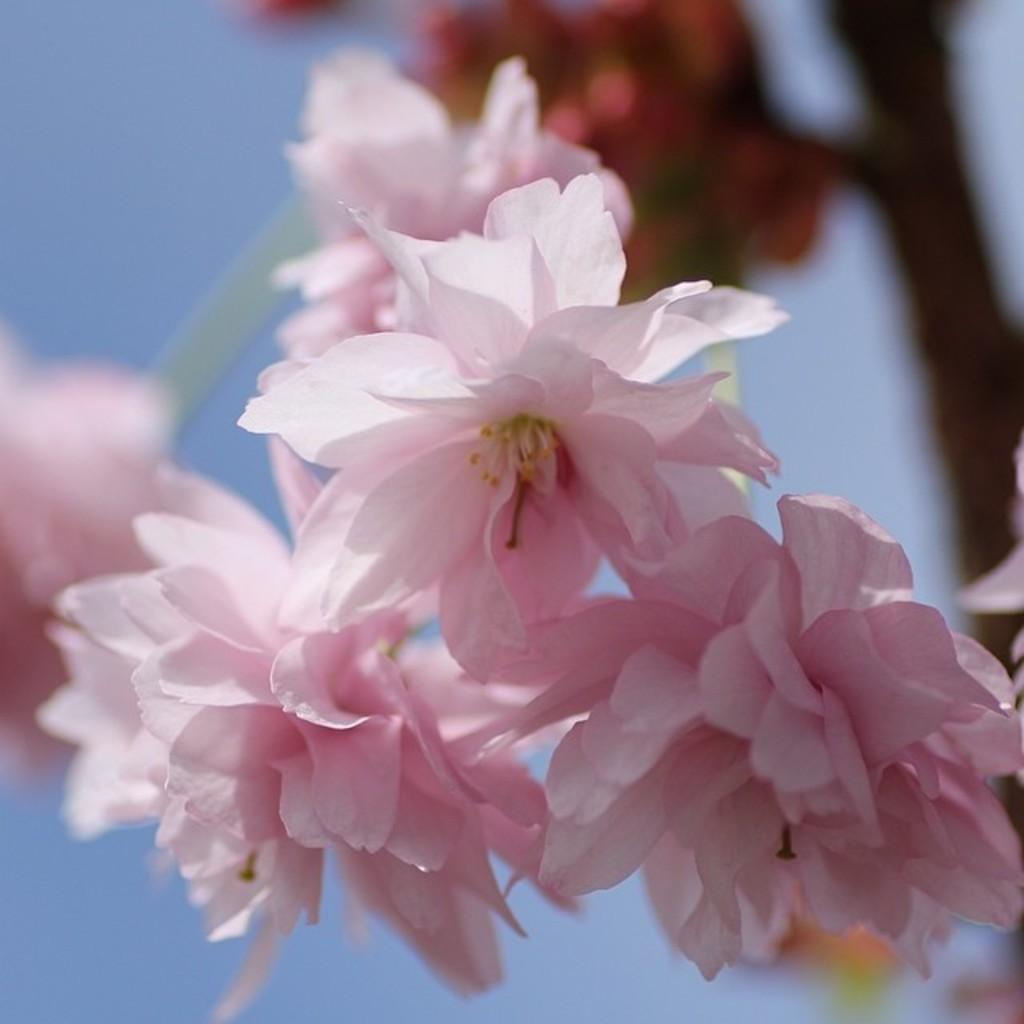What type of living organisms can be seen in the image? There are flowers in the image. Can you describe the background of the image? The background of the image is blurred. What type of match is being played in the image? There is no match or any indication of a game being played in the image; it features flowers and a blurred background. Is there a secretary visible in the image? There is no secretary or any human figure present in the image; it only features flowers and a blurred background. 